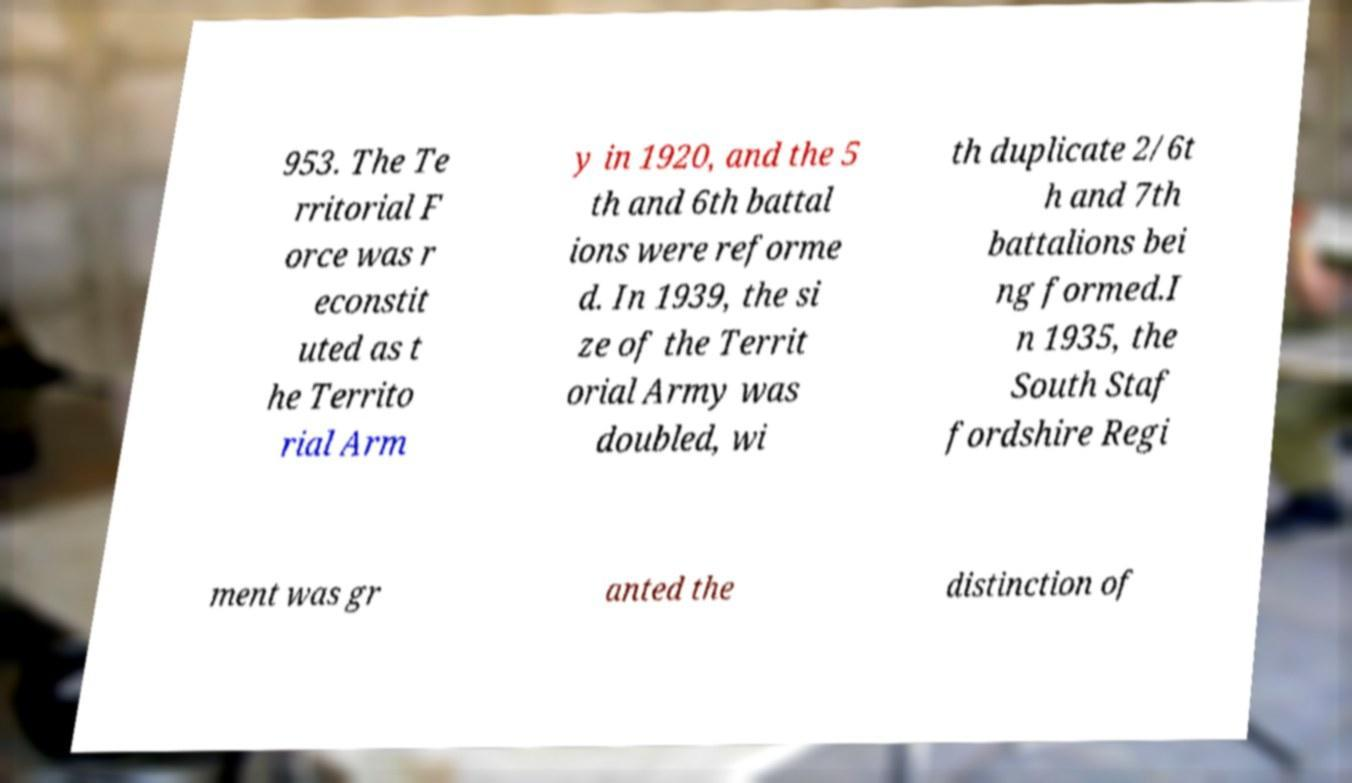There's text embedded in this image that I need extracted. Can you transcribe it verbatim? 953. The Te rritorial F orce was r econstit uted as t he Territo rial Arm y in 1920, and the 5 th and 6th battal ions were reforme d. In 1939, the si ze of the Territ orial Army was doubled, wi th duplicate 2/6t h and 7th battalions bei ng formed.I n 1935, the South Staf fordshire Regi ment was gr anted the distinction of 